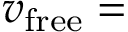Convert formula to latex. <formula><loc_0><loc_0><loc_500><loc_500>v _ { f r e e } =</formula> 